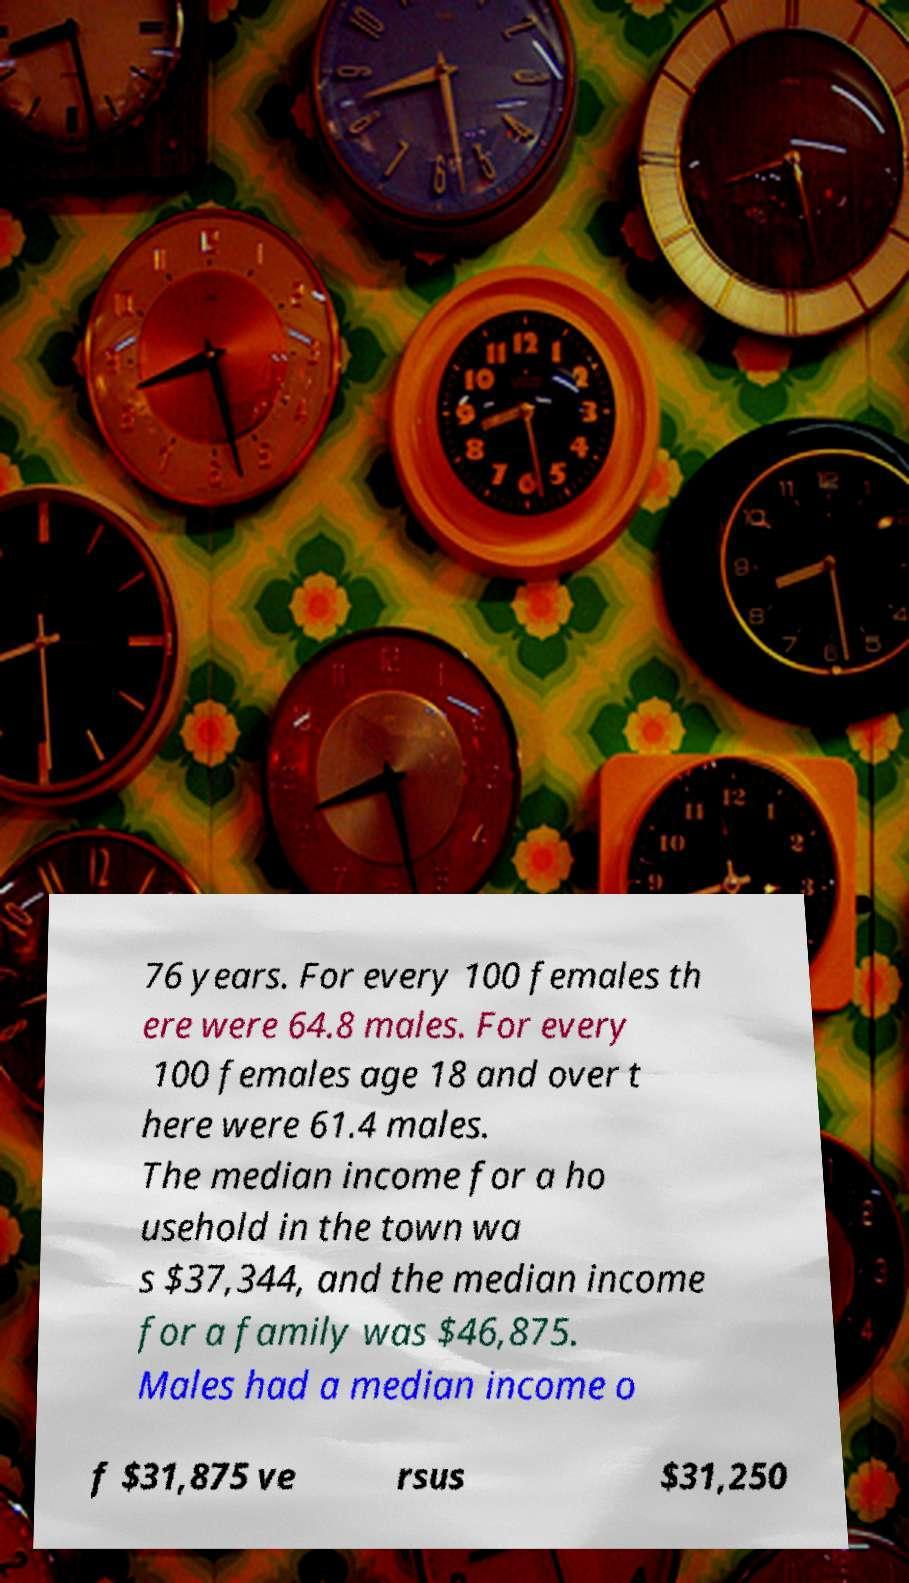I need the written content from this picture converted into text. Can you do that? 76 years. For every 100 females th ere were 64.8 males. For every 100 females age 18 and over t here were 61.4 males. The median income for a ho usehold in the town wa s $37,344, and the median income for a family was $46,875. Males had a median income o f $31,875 ve rsus $31,250 